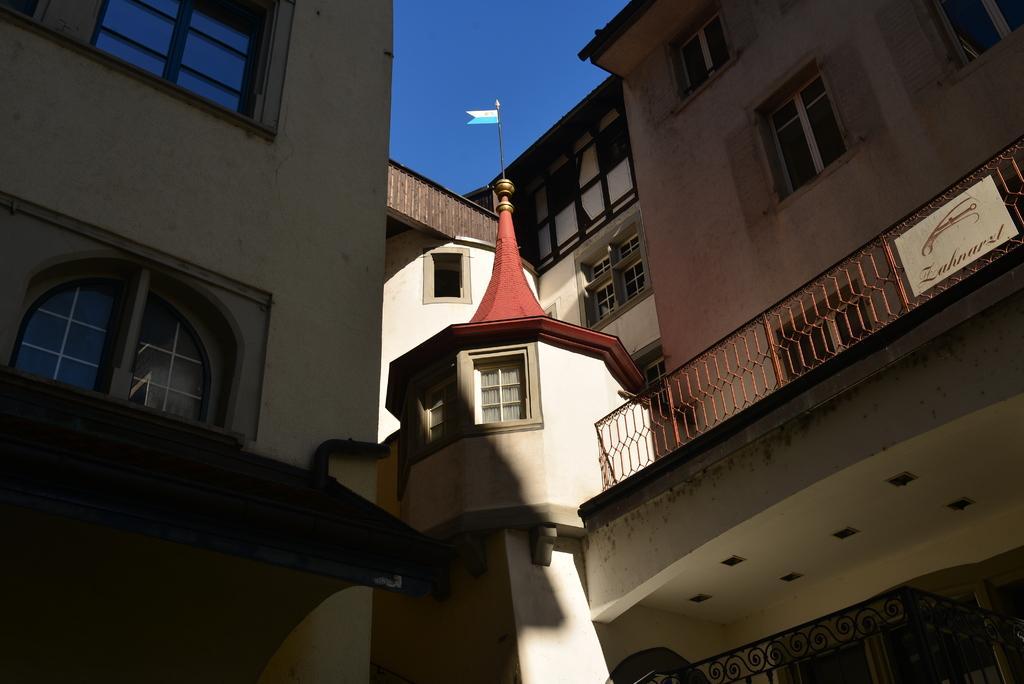Describe this image in one or two sentences. In this picture we can see there are buildings with windows. At the top of the image, there is the sky. On the right side of the image, there is a balcony. There is a pole with a flag. 